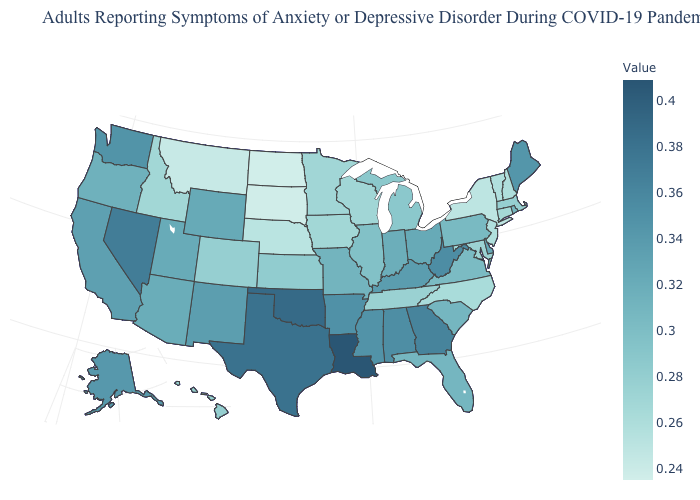Does Ohio have the highest value in the MidWest?
Keep it brief. Yes. Which states have the lowest value in the Northeast?
Quick response, please. New York. Among the states that border New Mexico , which have the lowest value?
Concise answer only. Colorado. Is the legend a continuous bar?
Keep it brief. Yes. Does Alaska have the lowest value in the USA?
Concise answer only. No. Which states have the highest value in the USA?
Concise answer only. Louisiana. Which states have the lowest value in the South?
Give a very brief answer. North Carolina. Does Tennessee have the highest value in the South?
Short answer required. No. 